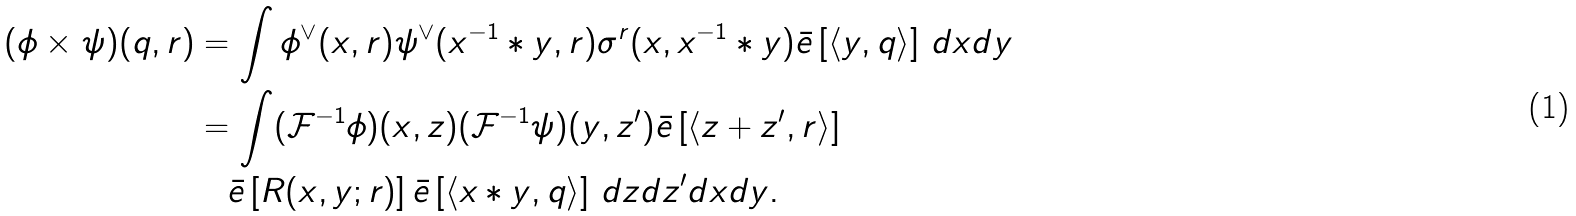Convert formula to latex. <formula><loc_0><loc_0><loc_500><loc_500>( \phi \times _ { } \psi ) ( q , r ) & = \int \phi ^ { \vee } ( x , r ) \psi ^ { \vee } ( x ^ { - 1 } * _ { } y , r ) \sigma _ { } ^ { r } ( x , x ^ { - 1 } * _ { } y ) \bar { e } \left [ \langle y , q \rangle \right ] \, d x d y \\ & = \int ( { \mathcal { F } } ^ { - 1 } \phi ) ( x , z ) ( { \mathcal { F } } ^ { - 1 } \psi ) ( y , z ^ { \prime } ) \bar { e } \left [ \langle z + z ^ { \prime } , r \rangle \right ] \\ & \quad \bar { e } \left [ R _ { } ( x , y ; r ) \right ] \bar { e } \left [ \langle x * _ { } y , q \rangle \right ] \, d z d z ^ { \prime } d x d y .</formula> 